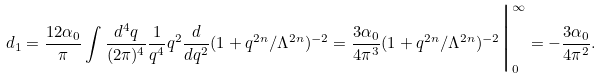<formula> <loc_0><loc_0><loc_500><loc_500>d _ { 1 } = \frac { 1 2 \alpha _ { 0 } } { \pi } \int \frac { d ^ { 4 } q } { ( 2 \pi ) ^ { 4 } } \frac { 1 } { q ^ { 4 } } q ^ { 2 } \frac { d } { d q ^ { 2 } } ( 1 + q ^ { 2 n } / \Lambda ^ { 2 n } ) ^ { - 2 } = \frac { 3 \alpha _ { 0 } } { 4 \pi ^ { 3 } } ( 1 + q ^ { 2 n } / \Lambda ^ { 2 n } ) ^ { - 2 } \Big | _ { 0 } ^ { \infty } = - \frac { 3 \alpha _ { 0 } } { 4 \pi ^ { 2 } } .</formula> 